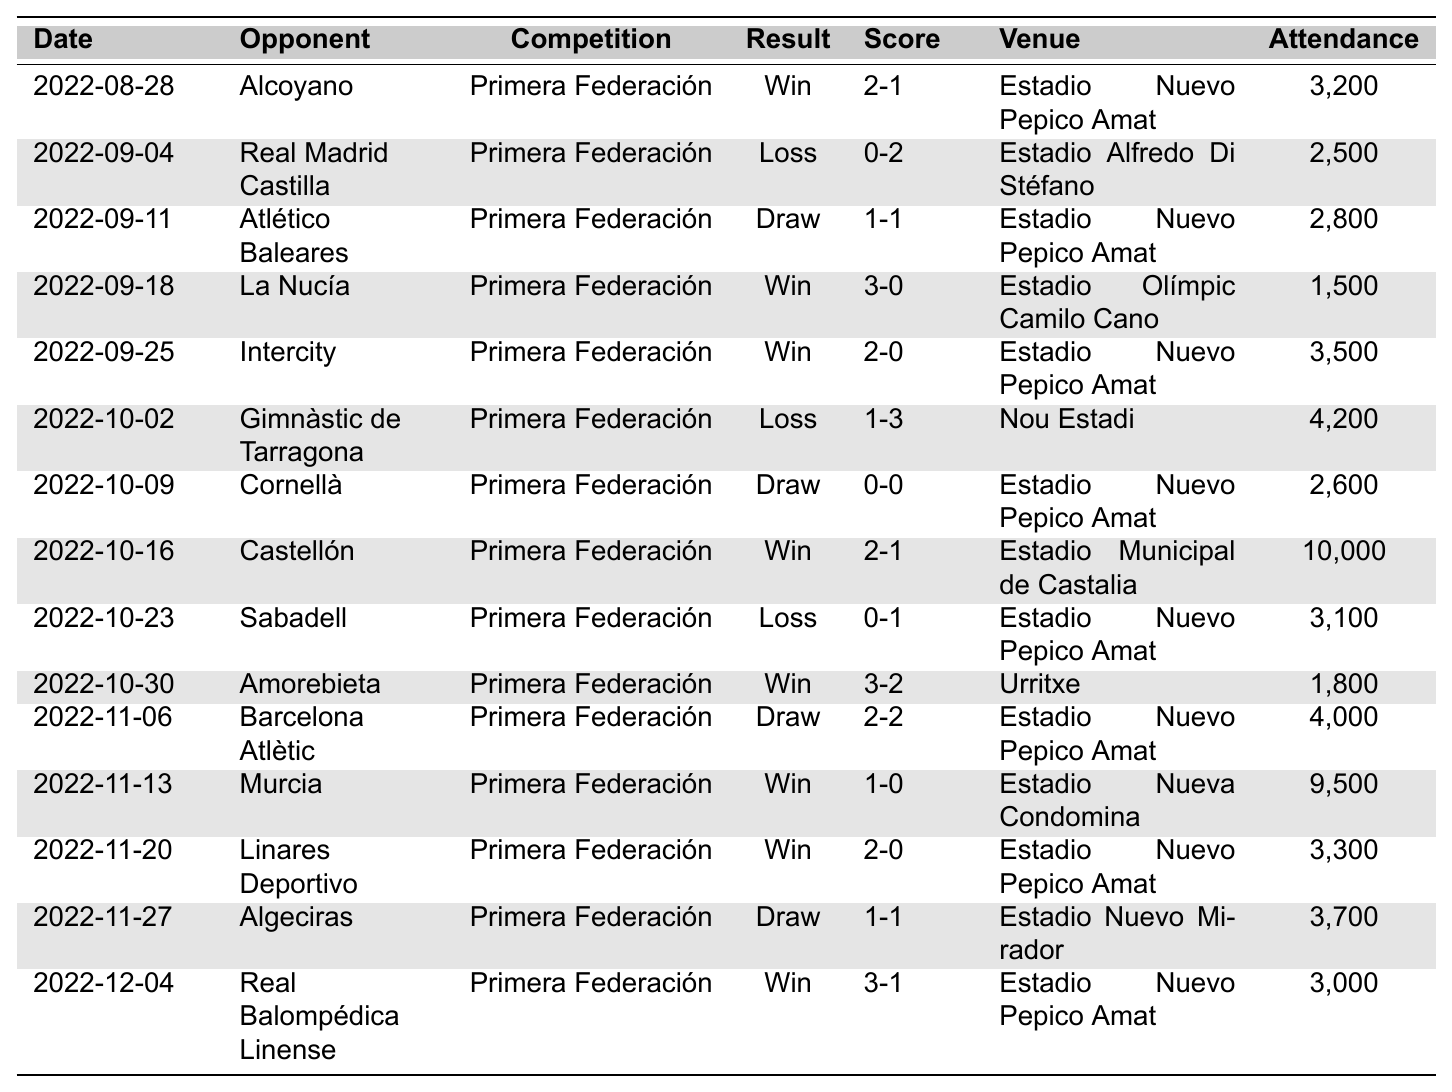What was the result of CD Eldense's match against Alcoyano on August 28, 2022? According to the data, the match against Alcoyano resulted in a 'Win' with a score of '2-1'.
Answer: Win Which match had the highest attendance in the 2022-2023 season? Looking at the attendance figures, the match against Castellón on October 16, 2022, had the highest attendance of 10,000.
Answer: 10,000 How many matches did CD Eldense win in the 2022-2023 season? Counting the 'Win' results in the table, CD Eldense won 6 matches.
Answer: 6 Did CD Eldense ever lose two matches in a row during the 2022-2023 season? No, upon reviewing the results, there is not a sequence of two consecutive losses present in the table.
Answer: No What is the overall result of CD Eldense's match against Real Madrid Castilla? The table indicates that CD Eldense lost to Real Madrid Castilla with a score of '0-2'.
Answer: Loss What is the average attendance for home games at Estadio Nuevo Pepico Amat? The home games listed at Estadio Nuevo Pepico Amat include wins against Alcoyano, Intercity, and Linares Deportivo, draws against Atlético Baleares and Cornellà, and a loss against Sabadell. The attendance numbers are 3,200, 3,500, 3,300, 2,800, 2,600, and 3,100, with a sum of 18,600. There are 6 games, so the average is 18,600 / 6 = 3,100.
Answer: 3,100 How many draws did CD Eldense have in the season? By checking the table, we see that there were 4 matches with a result of 'Draw'.
Answer: 4 In total, how many goals did CD Eldense score in their winning matches? Looking at the scores of the winning matches (2-1, 3-0, 2-0, 3-2, 1-0, and 2-0), the total goals scored is 2 + 3 + 2 + 3 + 1 + 2 = 13 goals in winning matches.
Answer: 13 How many games went into penalties, based on the results provided? The table does not indicate any matches that went into penalties, as all match results are categorized as Wins, Losses, or Draws.
Answer: 0 What percentage of matches ended in a win for CD Eldense in the 2022-2023 season? There are 15 matches in total, with 6 wins. To find the percentage, (6 wins / 15 total matches) * 100 = 40%.
Answer: 40% 